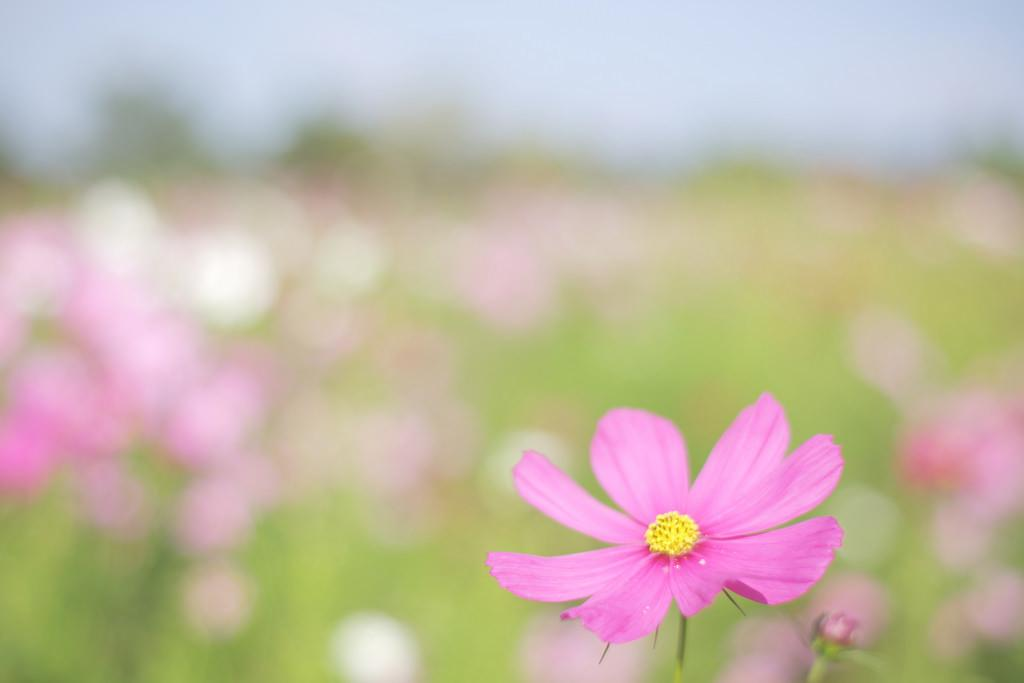What color is the flower on the right side of the image? The flower on the right side of the image is pink. Are there any other flowers in the image? Yes, there are pink color flowers in the background of the image. What type of vegetation can be seen in the background of the image? There are green color plants in the background of the image. What is visible at the top of the image? The sky is visible at the top of the image. How does the health of the donkey in the image improve over time? There is no donkey present in the image, nor does it provide any information about the health of any animals. 